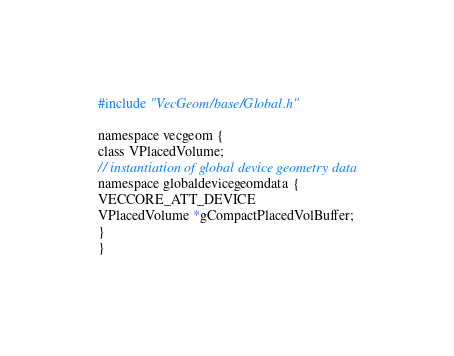<code> <loc_0><loc_0><loc_500><loc_500><_Cuda_>#include "VecGeom/base/Global.h"

namespace vecgeom {
class VPlacedVolume;
// instantiation of global device geometry data
namespace globaldevicegeomdata {
VECCORE_ATT_DEVICE
VPlacedVolume *gCompactPlacedVolBuffer;
}
}
</code> 